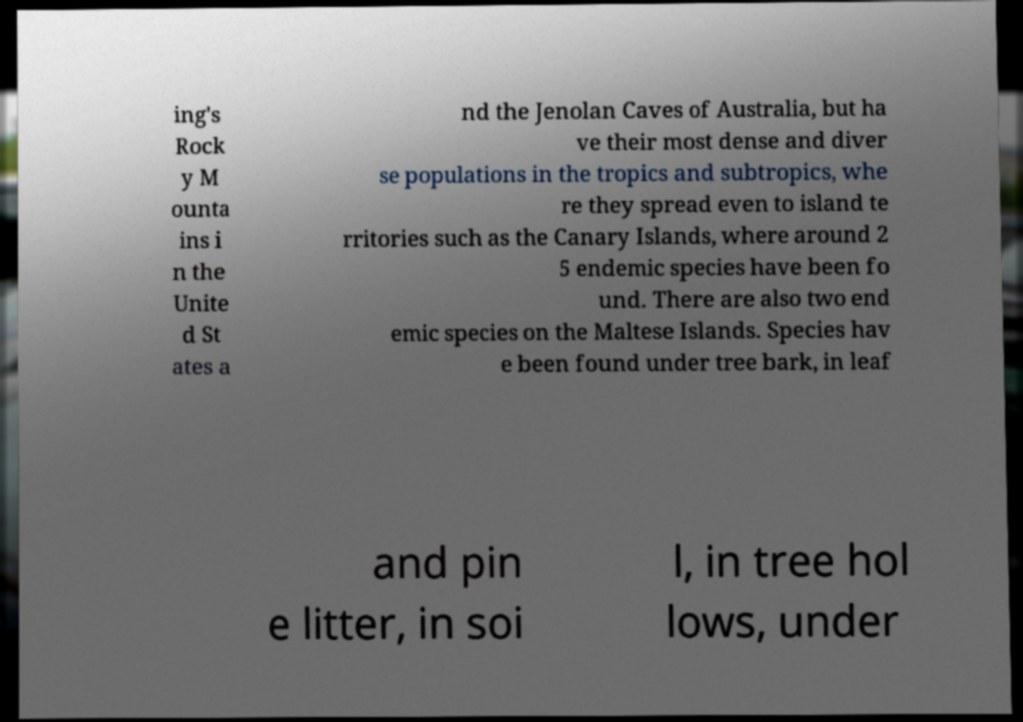Please read and relay the text visible in this image. What does it say? ing's Rock y M ounta ins i n the Unite d St ates a nd the Jenolan Caves of Australia, but ha ve their most dense and diver se populations in the tropics and subtropics, whe re they spread even to island te rritories such as the Canary Islands, where around 2 5 endemic species have been fo und. There are also two end emic species on the Maltese Islands. Species hav e been found under tree bark, in leaf and pin e litter, in soi l, in tree hol lows, under 